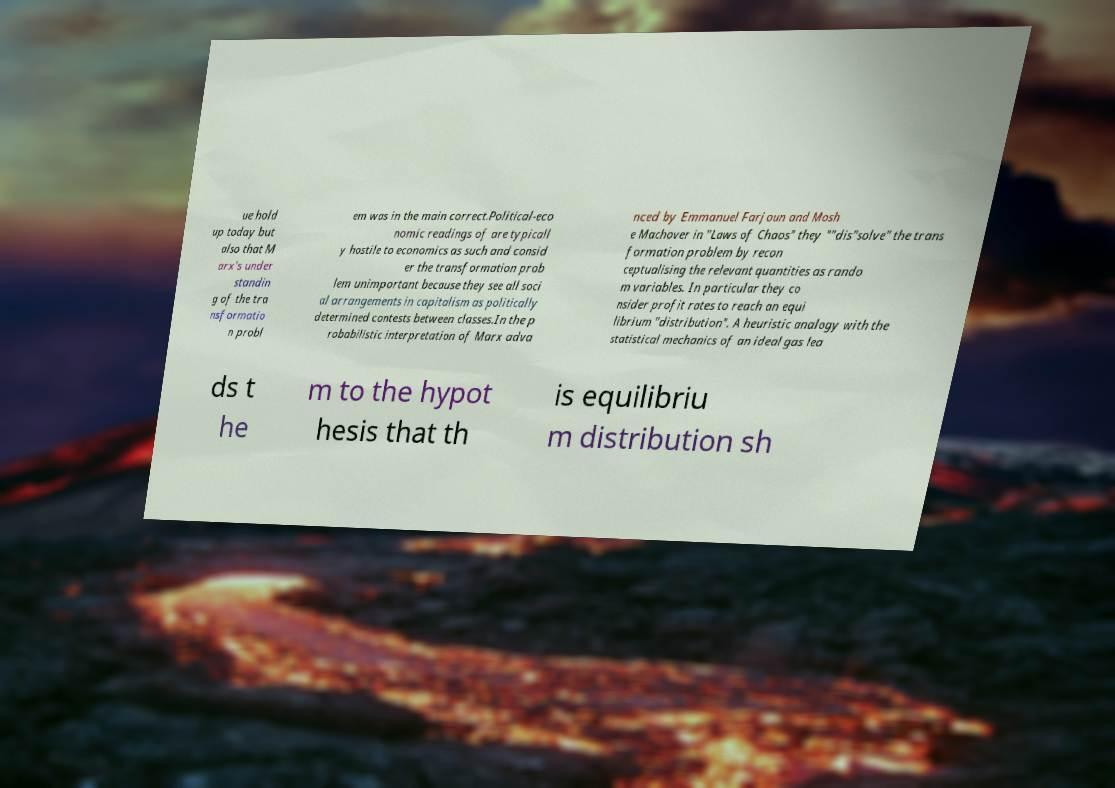I need the written content from this picture converted into text. Can you do that? ue hold up today but also that M arx's under standin g of the tra nsformatio n probl em was in the main correct.Political-eco nomic readings of are typicall y hostile to economics as such and consid er the transformation prob lem unimportant because they see all soci al arrangements in capitalism as politically determined contests between classes.In the p robabilistic interpretation of Marx adva nced by Emmanuel Farjoun and Mosh e Machover in "Laws of Chaos" they ""dis"solve" the trans formation problem by recon ceptualising the relevant quantities as rando m variables. In particular they co nsider profit rates to reach an equi librium "distribution". A heuristic analogy with the statistical mechanics of an ideal gas lea ds t he m to the hypot hesis that th is equilibriu m distribution sh 